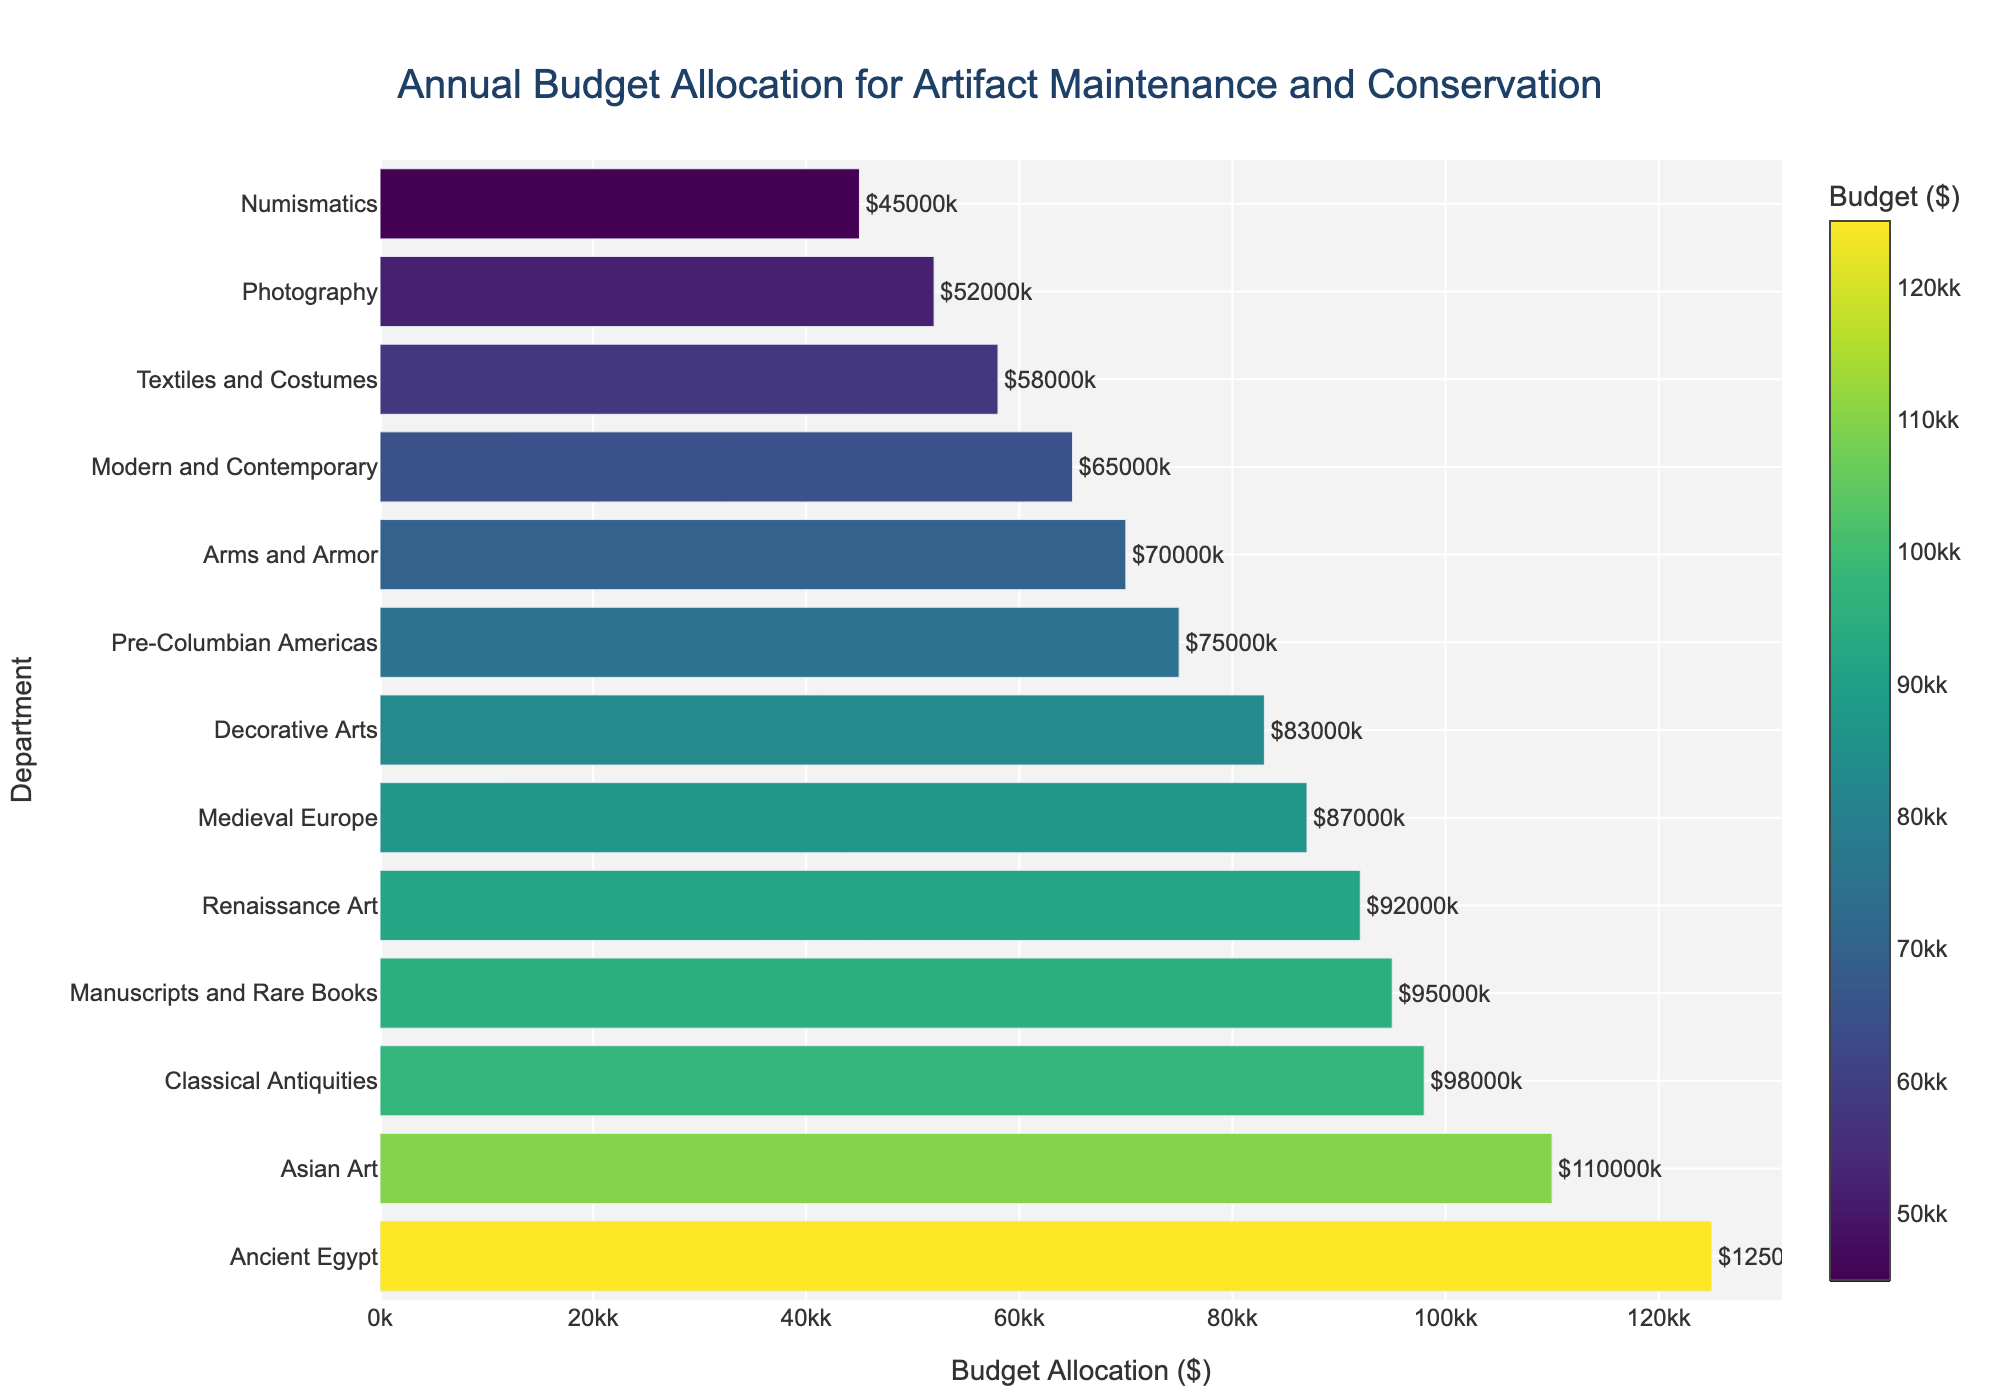What department has the highest annual budget allocation for artifact maintenance and conservation? The figure shows a horizontal bar chart sorted by budget allocation in descending order. The department with the longest bar at the top is Ancient Egypt, indicating it has the highest budget allocation.
Answer: Ancient Egypt What is the budget allocation for the Photography department? The Photography department is represented by a bar on the chart. The length of this bar corresponds to its budget allocation, which is labeled as $52,000.
Answer: $52,000 Which department has a lower budget allocation than Textiles and Costumes but higher than Arms and Armor? To answer this, we need to find the department with a budget between those for Textiles and Costumes ($58,000) and Arms and Armor ($70,000). The Decorative Arts department fits this criterion with a budget of $83,000.
Answer: Decorative Arts What is the total budget allocation for the Classical Antiquities and Asian Art departments combined? According to the chart, Classical Antiquities has a budget of $98,000 and Asian Art has a budget of $110,000. Adding these together gives 98,000 + 110,000 = 208,000.
Answer: $208,000 How does the budget allocation for Modern and Contemporary compare to that of Manuscripts and Rare Books? The chart shows that Modern and Contemporary has a budget of $65,000, while Manuscripts and Rare Books has a budget of $95,000. Manuscripts and Rare Books have a higher budget allocation.
Answer: Manuscripts and Rare Books have a higher budget Which department has the closest budget allocation to $75,000? The chart shows that the Pre-Columbian Americas department has a budget of $75,000.
Answer: Pre-Columbian Americas What is the difference in budget allocation between the highest and the lowest funded departments? The highest budget allocation is for Ancient Egypt ($125,000), and the lowest is for Numismatics ($45,000). The difference is 125,000 - 45,000 = 80,000.
Answer: $80,000 What visual cues indicate that the bar for Ancient Egypt represents the highest budget allocation? The bar's length for Ancient Egypt is the longest on the chart, and it is positioned at the top of the sorted chart. Additionally, its color is the most saturated, aligning with the highest value on the colorscale.
Answer: Longest bar, top position, most saturated color Which three departments have the smallest budget allocations, and what are their values? The chart shows that the departments with the smallest budgets are Numismatics ($45,000), Photography ($52,000), and Textiles and Costumes ($58,000).
Answer: Numismatics: $45,000, Photography: $52,000, Textiles and Costumes: $58,000 